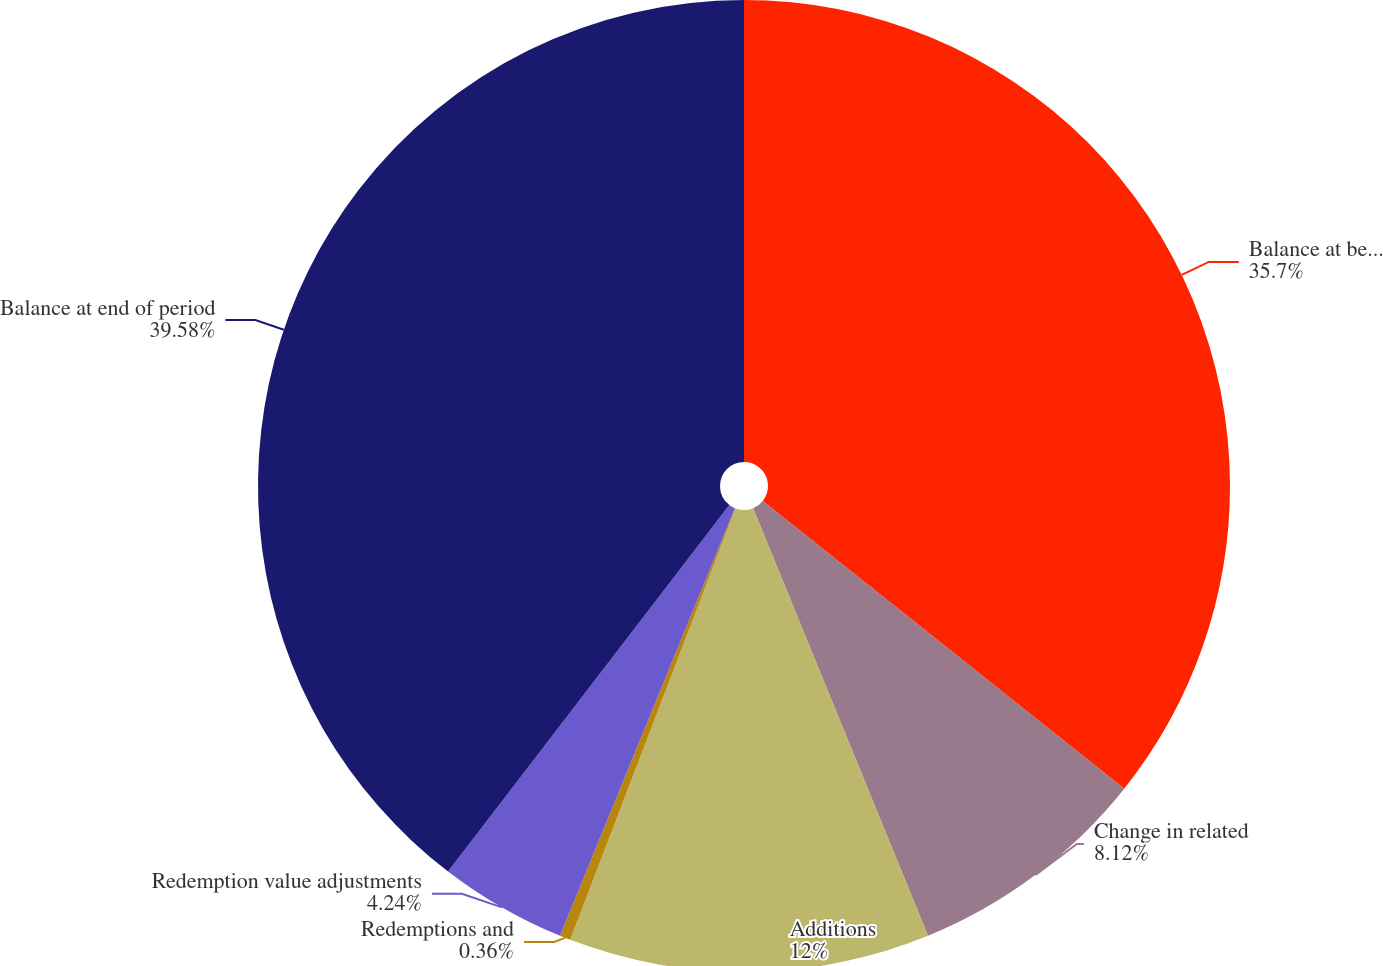Convert chart to OTSL. <chart><loc_0><loc_0><loc_500><loc_500><pie_chart><fcel>Balance at beginning of period<fcel>Change in related<fcel>Additions<fcel>Redemptions and<fcel>Redemption value adjustments<fcel>Balance at end of period<nl><fcel>35.7%<fcel>8.12%<fcel>12.0%<fcel>0.36%<fcel>4.24%<fcel>39.58%<nl></chart> 